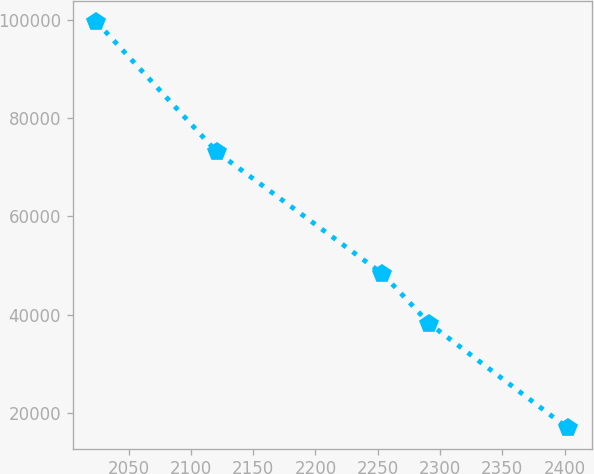Convert chart. <chart><loc_0><loc_0><loc_500><loc_500><line_chart><ecel><fcel>Unnamed: 1<nl><fcel>2024.18<fcel>99653.2<nl><fcel>2121.06<fcel>73087.2<nl><fcel>2253.73<fcel>48342.9<nl><fcel>2291.59<fcel>38140<nl><fcel>2402.73<fcel>16851.6<nl></chart> 